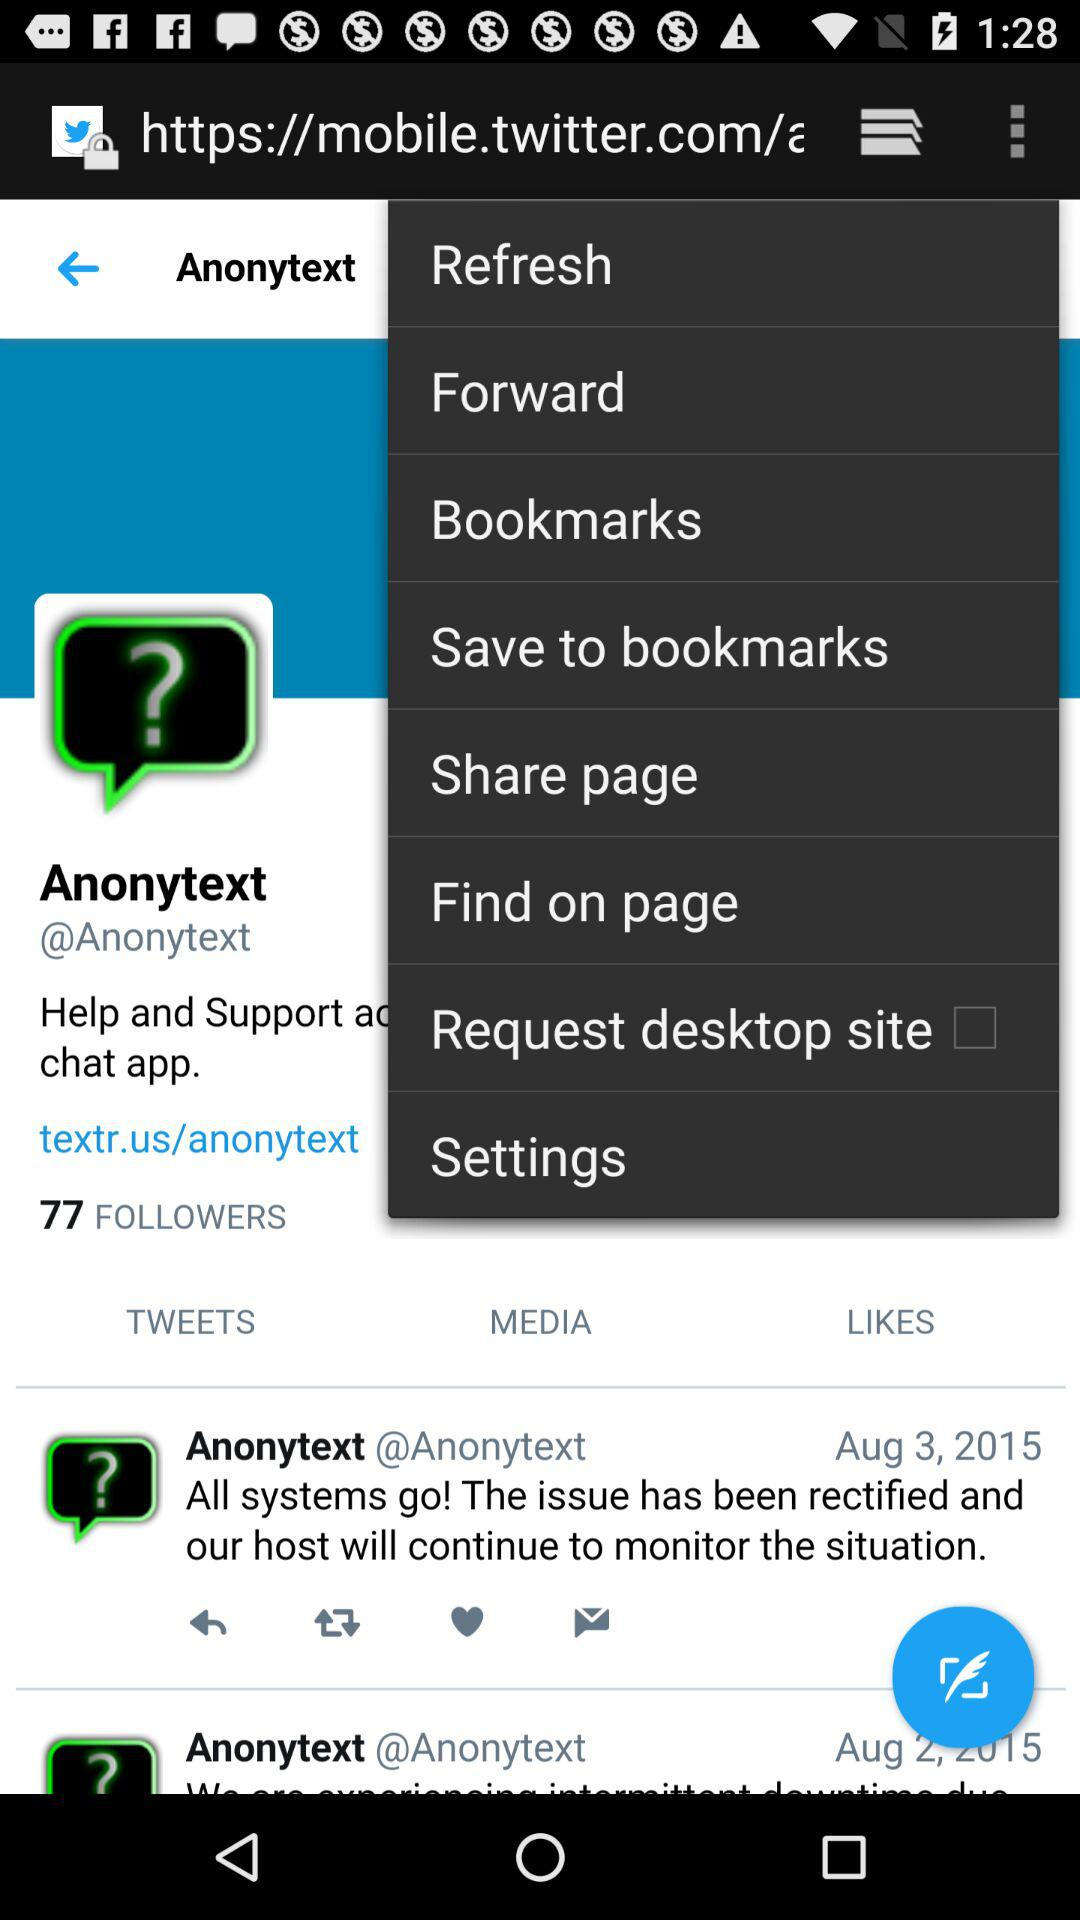What is the status of the "Request desktop site"? The status is "off". 